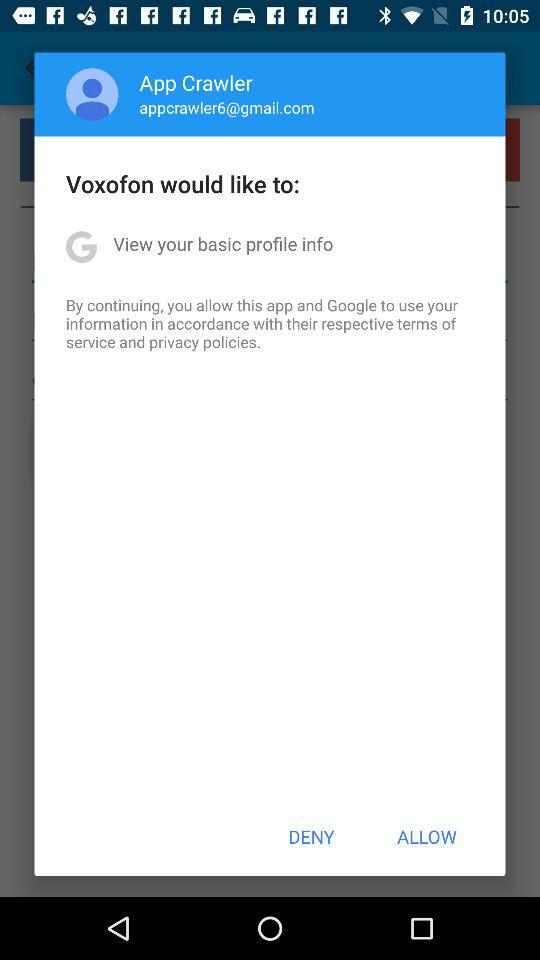What is the user's name? The user's name is App Crawler. 